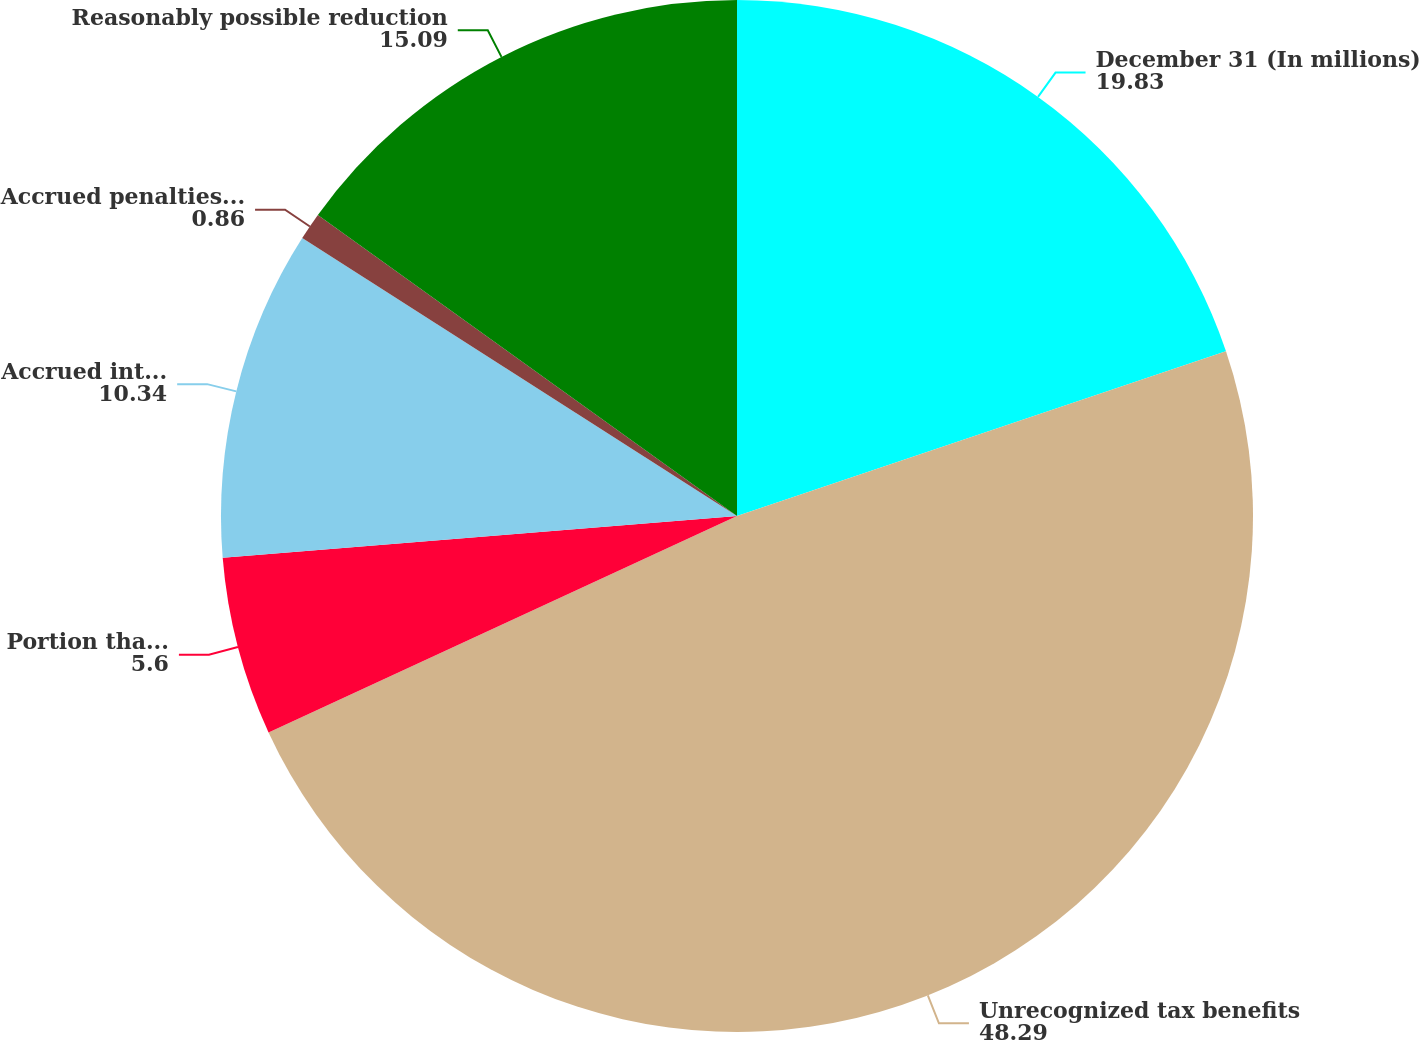Convert chart to OTSL. <chart><loc_0><loc_0><loc_500><loc_500><pie_chart><fcel>December 31 (In millions)<fcel>Unrecognized tax benefits<fcel>Portion that if recognized<fcel>Accrued interest on<fcel>Accrued penalties on<fcel>Reasonably possible reduction<nl><fcel>19.83%<fcel>48.29%<fcel>5.6%<fcel>10.34%<fcel>0.86%<fcel>15.09%<nl></chart> 